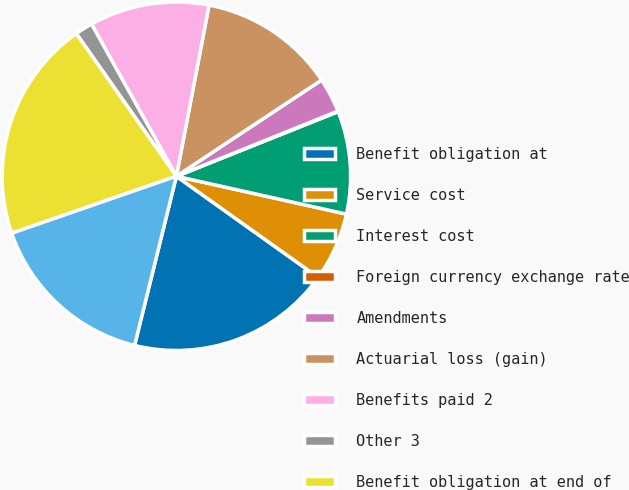Convert chart to OTSL. <chart><loc_0><loc_0><loc_500><loc_500><pie_chart><fcel>Benefit obligation at<fcel>Service cost<fcel>Interest cost<fcel>Foreign currency exchange rate<fcel>Amendments<fcel>Actuarial loss (gain)<fcel>Benefits paid 2<fcel>Other 3<fcel>Benefit obligation at end of<fcel>Fair value of plan assets at<nl><fcel>19.0%<fcel>6.37%<fcel>9.53%<fcel>0.06%<fcel>3.21%<fcel>12.68%<fcel>11.1%<fcel>1.64%<fcel>20.57%<fcel>15.84%<nl></chart> 